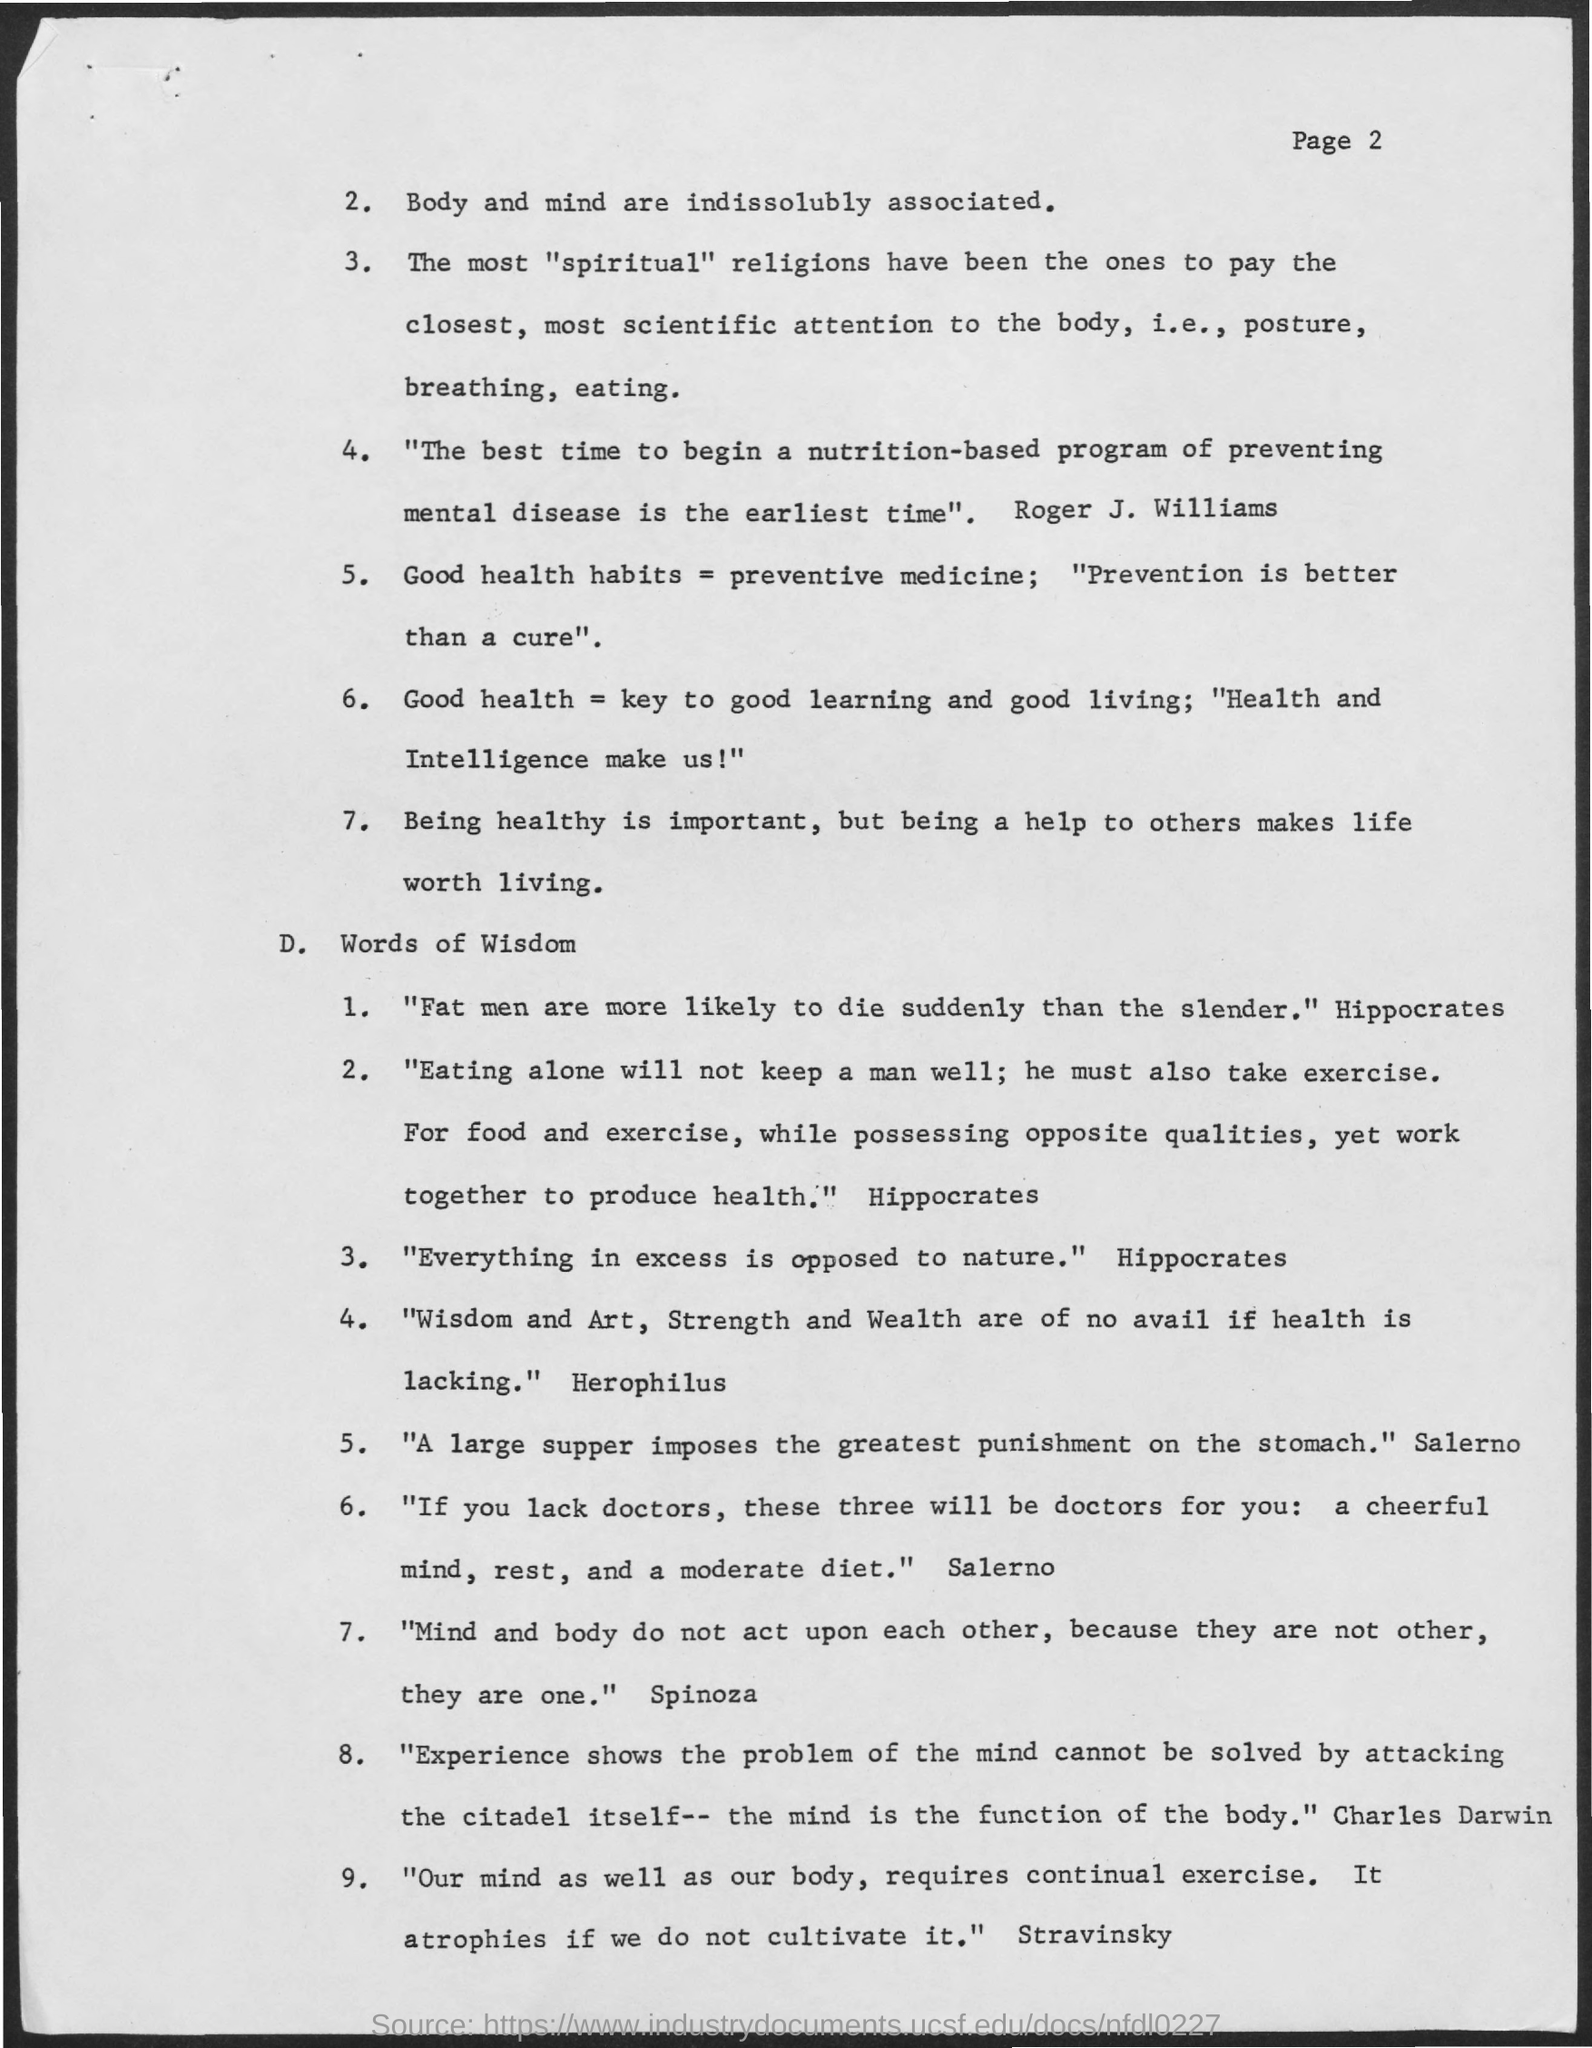List a handful of essential elements in this visual. Spinoza wrote that 'mind and body do not act upon each other because they are not other, they are one.' 